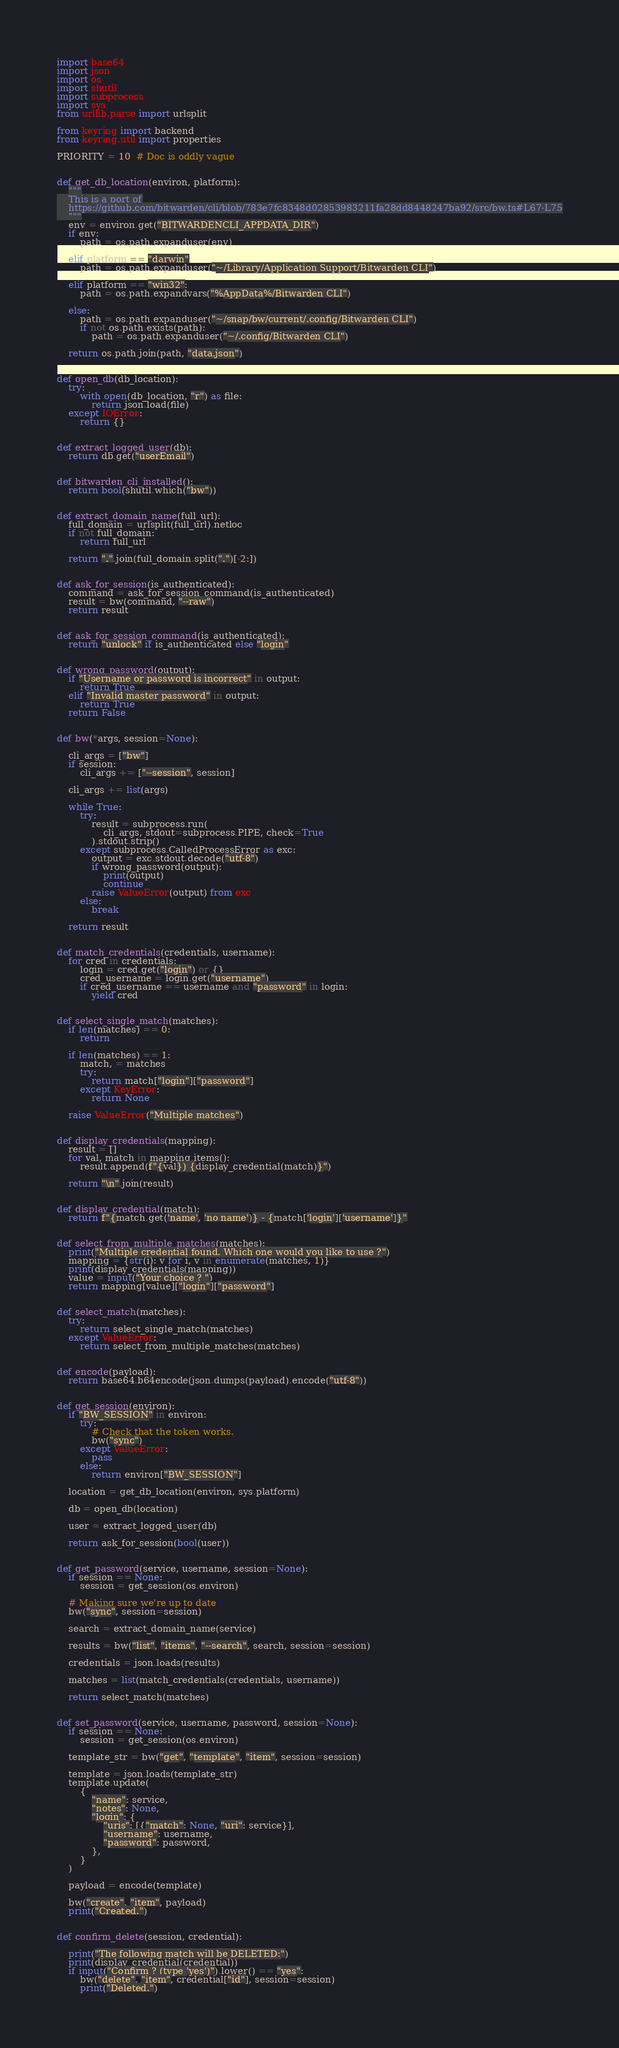<code> <loc_0><loc_0><loc_500><loc_500><_Python_>import base64
import json
import os
import shutil
import subprocess
import sys
from urllib.parse import urlsplit

from keyring import backend
from keyring.util import properties

PRIORITY = 10  # Doc is oddly vague


def get_db_location(environ, platform):
    """
    This is a port of
    https://github.com/bitwarden/cli/blob/783e7fc8348d02853983211fa28dd8448247ba92/src/bw.ts#L67-L75
    """
    env = environ.get("BITWARDENCLI_APPDATA_DIR")
    if env:
        path = os.path.expanduser(env)

    elif platform == "darwin":
        path = os.path.expanduser("~/Library/Application Support/Bitwarden CLI")

    elif platform == "win32":
        path = os.path.expandvars("%AppData%/Bitwarden CLI")

    else:
        path = os.path.expanduser("~/snap/bw/current/.config/Bitwarden CLI")
        if not os.path.exists(path):
            path = os.path.expanduser("~/.config/Bitwarden CLI")

    return os.path.join(path, "data.json")


def open_db(db_location):
    try:
        with open(db_location, "r") as file:
            return json.load(file)
    except IOError:
        return {}


def extract_logged_user(db):
    return db.get("userEmail")


def bitwarden_cli_installed():
    return bool(shutil.which("bw"))


def extract_domain_name(full_url):
    full_domain = urlsplit(full_url).netloc
    if not full_domain:
        return full_url

    return ".".join(full_domain.split(".")[-2:])


def ask_for_session(is_authenticated):
    command = ask_for_session_command(is_authenticated)
    result = bw(command, "--raw")
    return result


def ask_for_session_command(is_authenticated):
    return "unlock" if is_authenticated else "login"


def wrong_password(output):
    if "Username or password is incorrect" in output:
        return True
    elif "Invalid master password" in output:
        return True
    return False


def bw(*args, session=None):

    cli_args = ["bw"]
    if session:
        cli_args += ["--session", session]

    cli_args += list(args)

    while True:
        try:
            result = subprocess.run(
                cli_args, stdout=subprocess.PIPE, check=True
            ).stdout.strip()
        except subprocess.CalledProcessError as exc:
            output = exc.stdout.decode("utf-8")
            if wrong_password(output):
                print(output)
                continue
            raise ValueError(output) from exc
        else:
            break

    return result


def match_credentials(credentials, username):
    for cred in credentials:
        login = cred.get("login") or {}
        cred_username = login.get("username")
        if cred_username == username and "password" in login:
            yield cred


def select_single_match(matches):
    if len(matches) == 0:
        return

    if len(matches) == 1:
        match, = matches
        try:
            return match["login"]["password"]
        except KeyError:
            return None

    raise ValueError("Multiple matches")


def display_credentials(mapping):
    result = []
    for val, match in mapping.items():
        result.append(f"{val}) {display_credential(match)}")

    return "\n".join(result)


def display_credential(match):
    return f"{match.get('name', 'no name')} - {match['login']['username']}"


def select_from_multiple_matches(matches):
    print("Multiple credential found. Which one would you like to use ?")
    mapping = {str(i): v for i, v in enumerate(matches, 1)}
    print(display_credentials(mapping))
    value = input("Your choice ? ")
    return mapping[value]["login"]["password"]


def select_match(matches):
    try:
        return select_single_match(matches)
    except ValueError:
        return select_from_multiple_matches(matches)


def encode(payload):
    return base64.b64encode(json.dumps(payload).encode("utf-8"))


def get_session(environ):
    if "BW_SESSION" in environ:
        try:
            # Check that the token works.
            bw("sync")
        except ValueError:
            pass
        else:
            return environ["BW_SESSION"]

    location = get_db_location(environ, sys.platform)

    db = open_db(location)

    user = extract_logged_user(db)

    return ask_for_session(bool(user))


def get_password(service, username, session=None):
    if session == None:
        session = get_session(os.environ)

    # Making sure we're up to date
    bw("sync", session=session)

    search = extract_domain_name(service)

    results = bw("list", "items", "--search", search, session=session)

    credentials = json.loads(results)

    matches = list(match_credentials(credentials, username))

    return select_match(matches)


def set_password(service, username, password, session=None):
    if session == None:
        session = get_session(os.environ)

    template_str = bw("get", "template", "item", session=session)

    template = json.loads(template_str)
    template.update(
        {
            "name": service,
            "notes": None,
            "login": {
                "uris": [{"match": None, "uri": service}],
                "username": username,
                "password": password,
            },
        }
    )

    payload = encode(template)

    bw("create", "item", payload)
    print("Created.")


def confirm_delete(session, credential):

    print("The following match will be DELETED:")
    print(display_credential(credential))
    if input("Confirm ? (type 'yes')").lower() == "yes":
        bw("delete", "item", credential["id"], session=session)
        print("Deleted.")</code> 